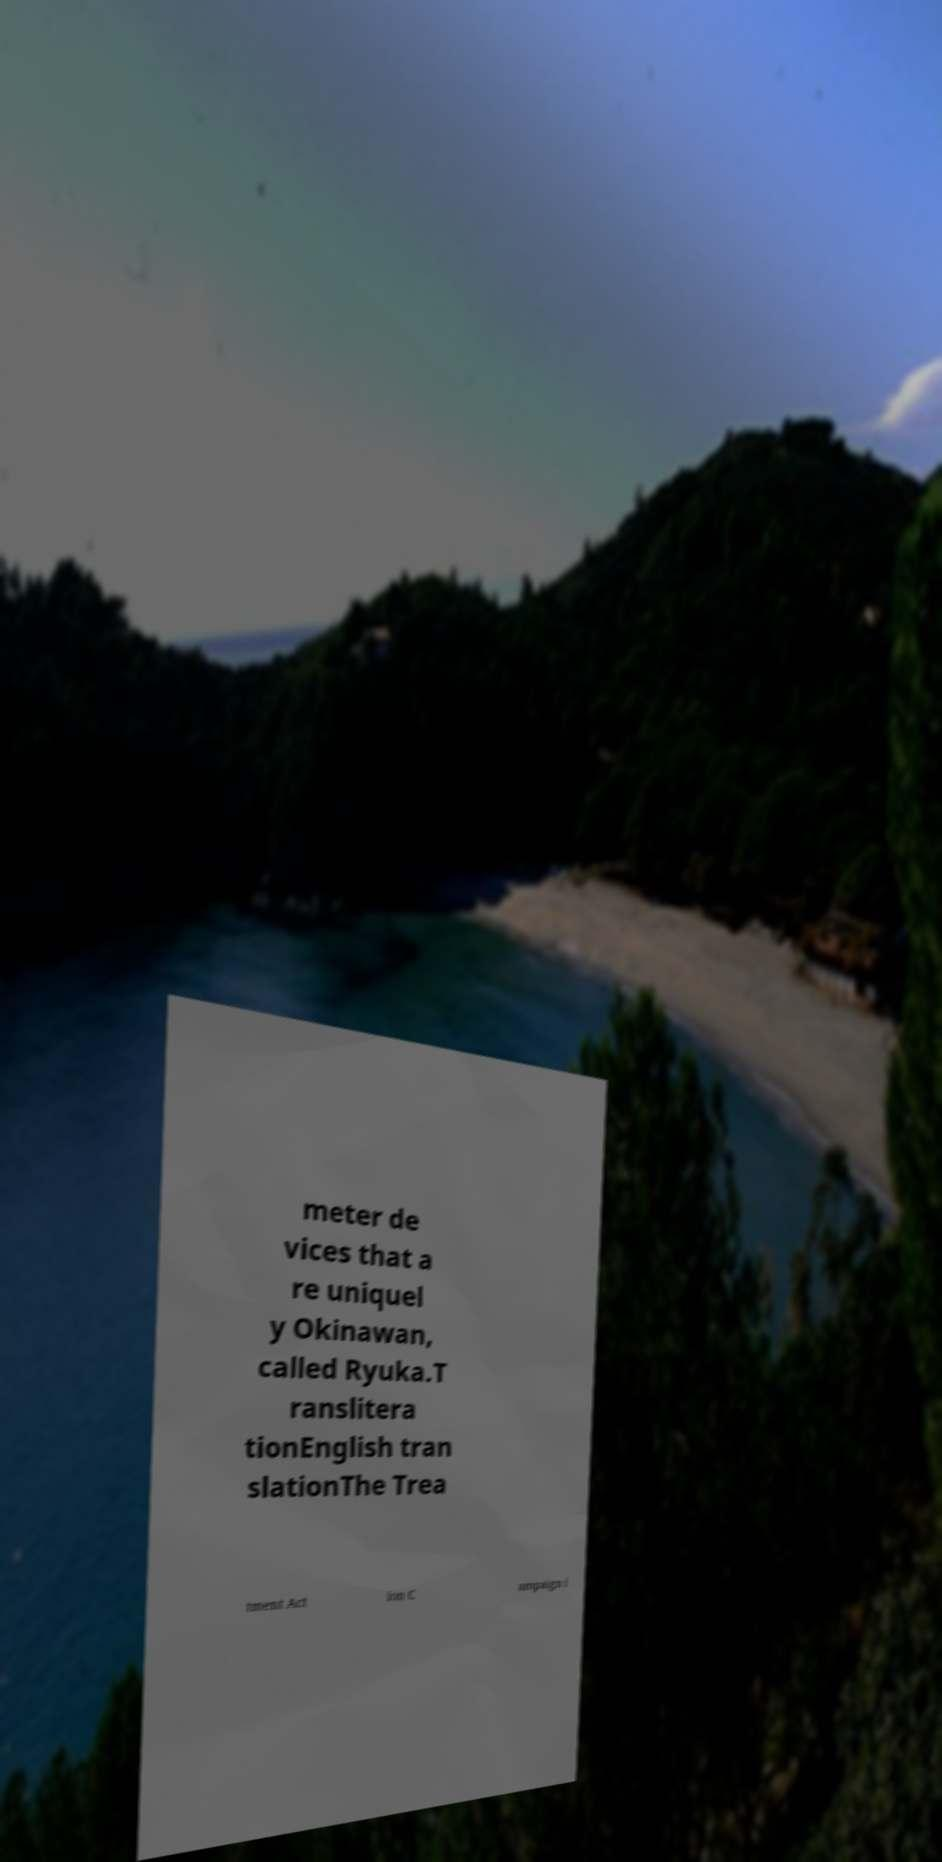Please identify and transcribe the text found in this image. meter de vices that a re uniquel y Okinawan, called Ryuka.T ranslitera tionEnglish tran slationThe Trea tment Act ion C ampaign i 